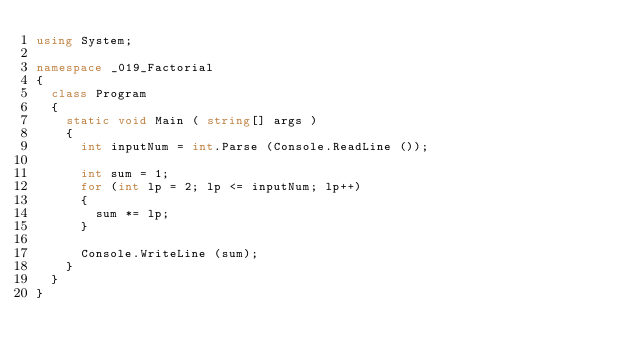<code> <loc_0><loc_0><loc_500><loc_500><_C#_>using System;

namespace _019_Factorial
{
	class Program
	{
		static void Main ( string[] args )
		{
			int inputNum = int.Parse (Console.ReadLine ());

			int sum = 1;
			for (int lp = 2; lp <= inputNum; lp++)
			{
				sum *= lp;
			}
			
			Console.WriteLine (sum);
		}
	}
}</code> 